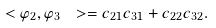Convert formula to latex. <formula><loc_0><loc_0><loc_500><loc_500>\ < \varphi _ { 2 } , \varphi _ { 3 } \ > = c _ { 2 1 } c _ { 3 1 } + c _ { 2 2 } c _ { 3 2 } .</formula> 